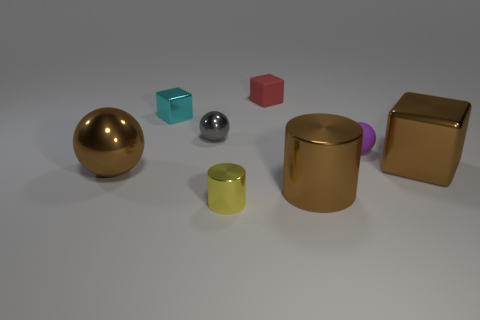Which objects in the image appear to be reflective, and can you infer anything about the setting from their reflections? The gold sphere, the small silver sphere, and the gold metallic block all have reflective surfaces. Their reflections reveal a muted environment with a light source overhead, suggesting an indoor setting with minimal surrounding detail to be reflected on their surfaces. 